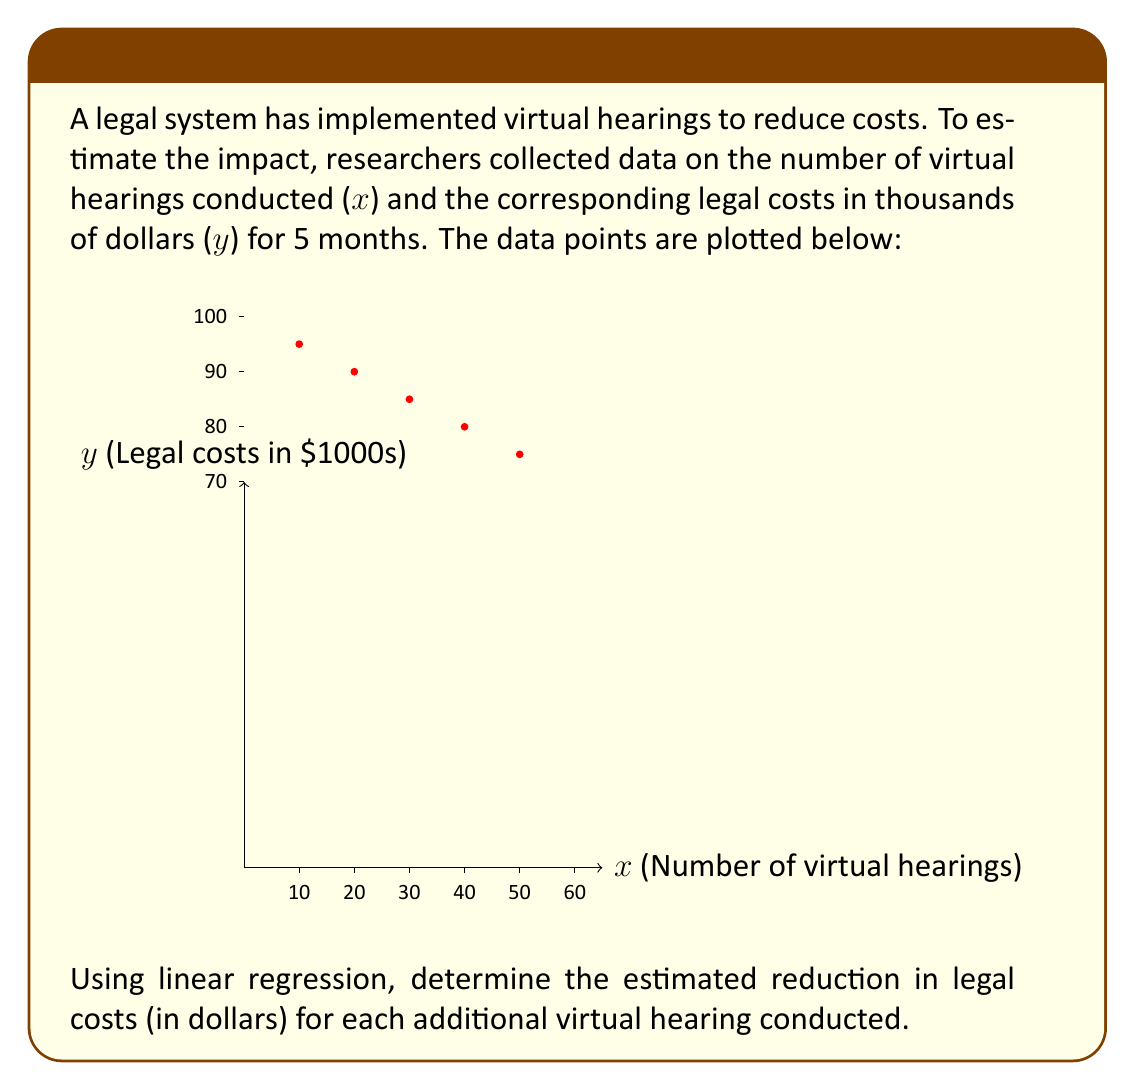Solve this math problem. To solve this problem using linear regression, we'll follow these steps:

1) First, we need to calculate the means of x and y:
   $\bar{x} = \frac{10+20+30+40+50}{5} = 30$
   $\bar{y} = \frac{95+90+85+80+75}{5} = 85$

2) Now, we'll calculate the slope (b) using the formula:
   $b = \frac{\sum(x_i - \bar{x})(y_i - \bar{y})}{\sum(x_i - \bar{x})^2}$

3) Let's calculate the numerator and denominator separately:
   Numerator: $(-20)(-10) + (-10)(-5) + (0)(0) + (10)(5) + (20)(10) = 500$
   Denominator: $(-20)^2 + (-10)^2 + (0)^2 + (10)^2 + (20)^2 = 1000$

4) Now we can calculate the slope:
   $b = \frac{500}{1000} = -0.5$

5) The slope represents the change in y for each unit change in x. In this case, it's negative, indicating a decrease in legal costs as the number of virtual hearings increases.

6) To convert the slope to dollars, we multiply by 1000 (since y is in thousands of dollars):
   $-0.5 * 1000 = -500$
Answer: $500 